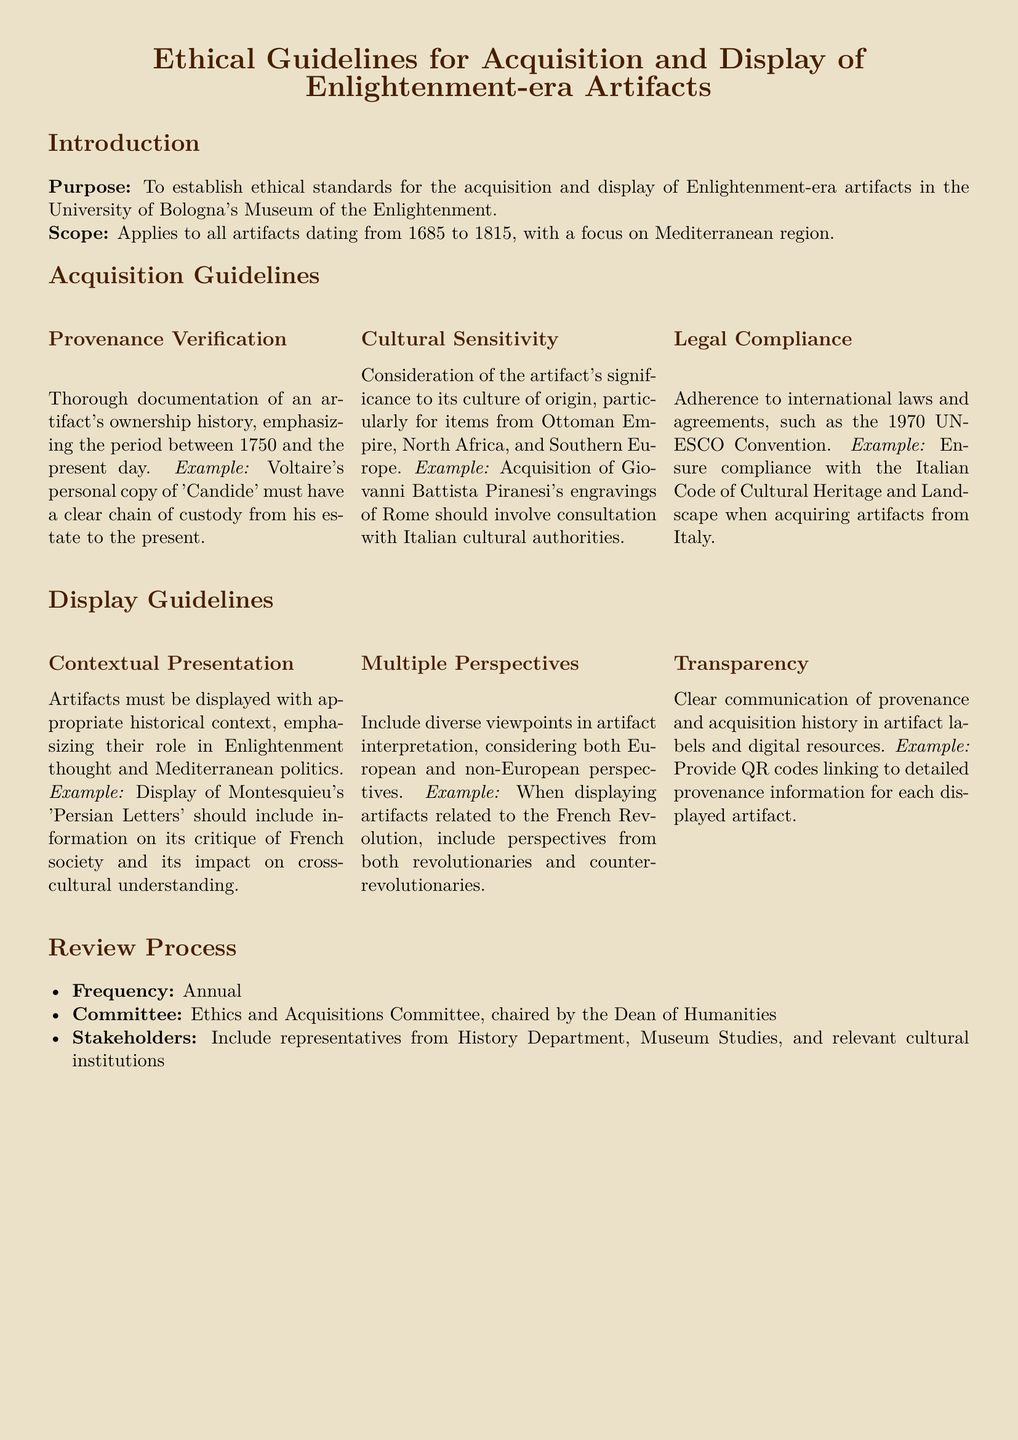What is the purpose of the ethical guidelines? The purpose is to establish ethical standards for the acquisition and display of Enlightenment-era artifacts in the University of Bologna's Museum of the Enlightenment.
Answer: To establish ethical standards What is the date range for the artifacts covered in the guidelines? The guidelines apply to all artifacts dating from 1685 to 1815.
Answer: 1685 to 1815 Who must verify provenance? Provenance verification is emphasized and must be thorough for all acquisitions.
Answer: Ethics and Acquisitions Committee What international agreement must be complied with? The guidelines specify adherence to international laws and agreements, particularly the 1970 UNESCO Convention.
Answer: 1970 UNESCO Convention What is included in the annual review process? The review process includes frequency, committee details, and stakeholder participation.
Answer: Annual Which historical figure’s work is mentioned for contextual presentation? Montesquieu's 'Persian Letters' is given as an example for contextual presentation.
Answer: Montesquieu What is emphasized when displaying artifacts? The display guidelines emphasize multiple perspectives in artifact interpretation.
Answer: Multiple perspectives Who chairs the Ethics and Acquisitions Committee? The Dean of Humanities chairs the committee according to the document.
Answer: Dean of Humanities 